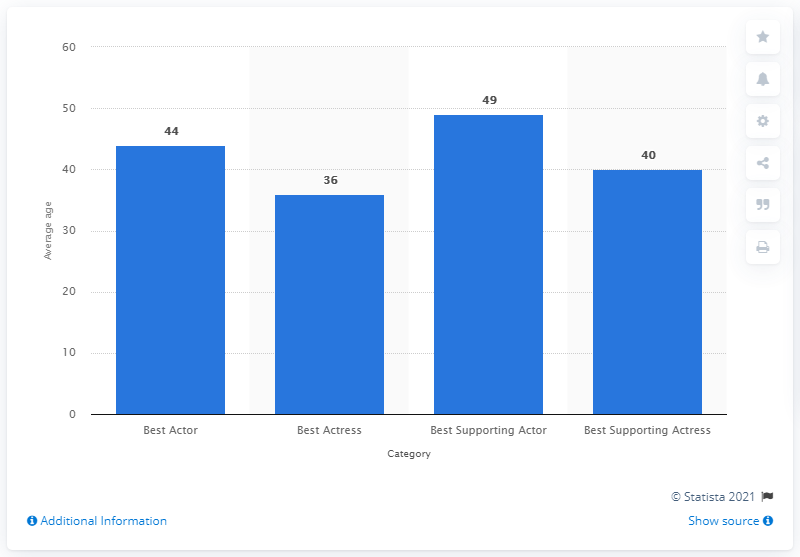Specify some key components in this picture. The average of all four bars is 42.25. The value for Best Actress is 36. The average age of a Best Actor winner between 1929 and 2018 is 44. 